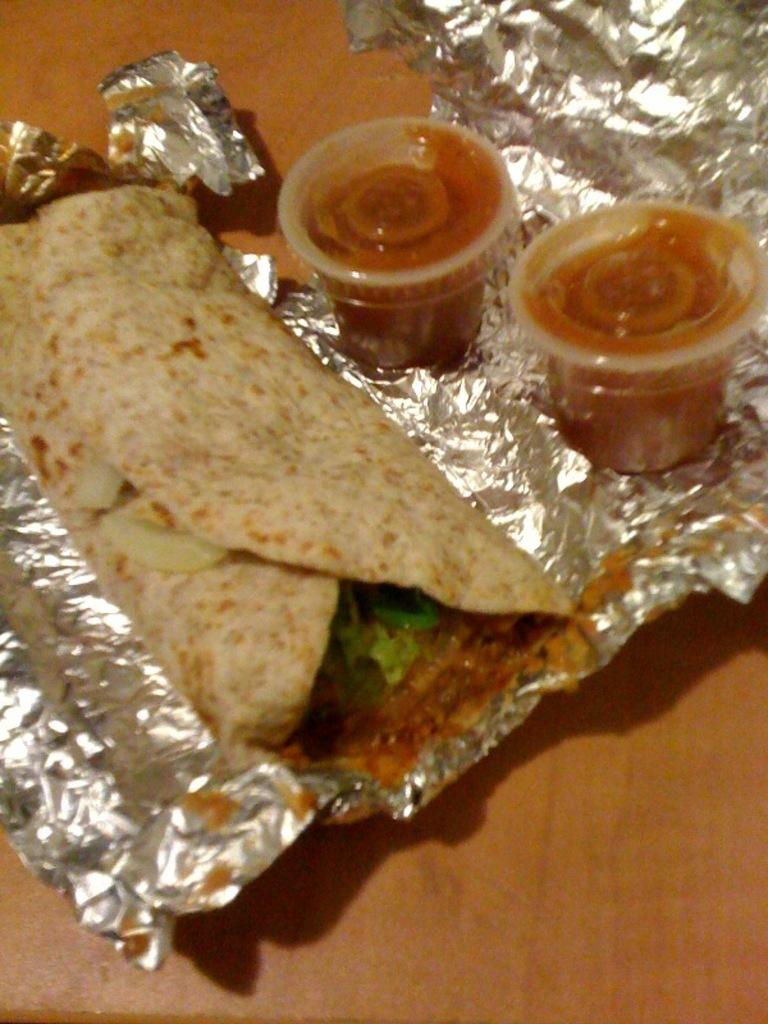What is the main subject of the image? There is a food item in the image. What accompanies the food item in the image? There are two cups of sauce in the image. On what surface are the food item and cups of sauce placed? The food item and cups of sauce are on a silver foil paper. What is the silver foil paper placed on? The silver foil paper is on a wooden object. Can you tell me how many employees work for the company in the image? There is no company or employees present in the image; it features a food item, cups of sauce, and a wooden object. What type of pancake is being flipped in the image? There is no pancake or flipping action present in the image. 